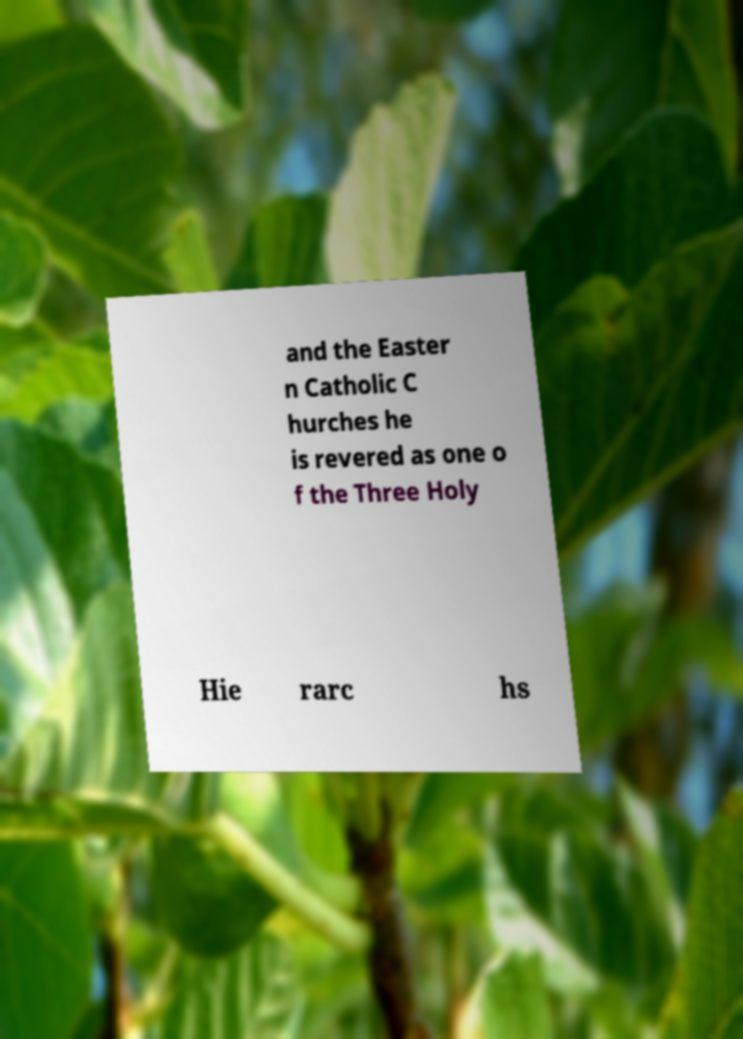Can you accurately transcribe the text from the provided image for me? and the Easter n Catholic C hurches he is revered as one o f the Three Holy Hie rarc hs 